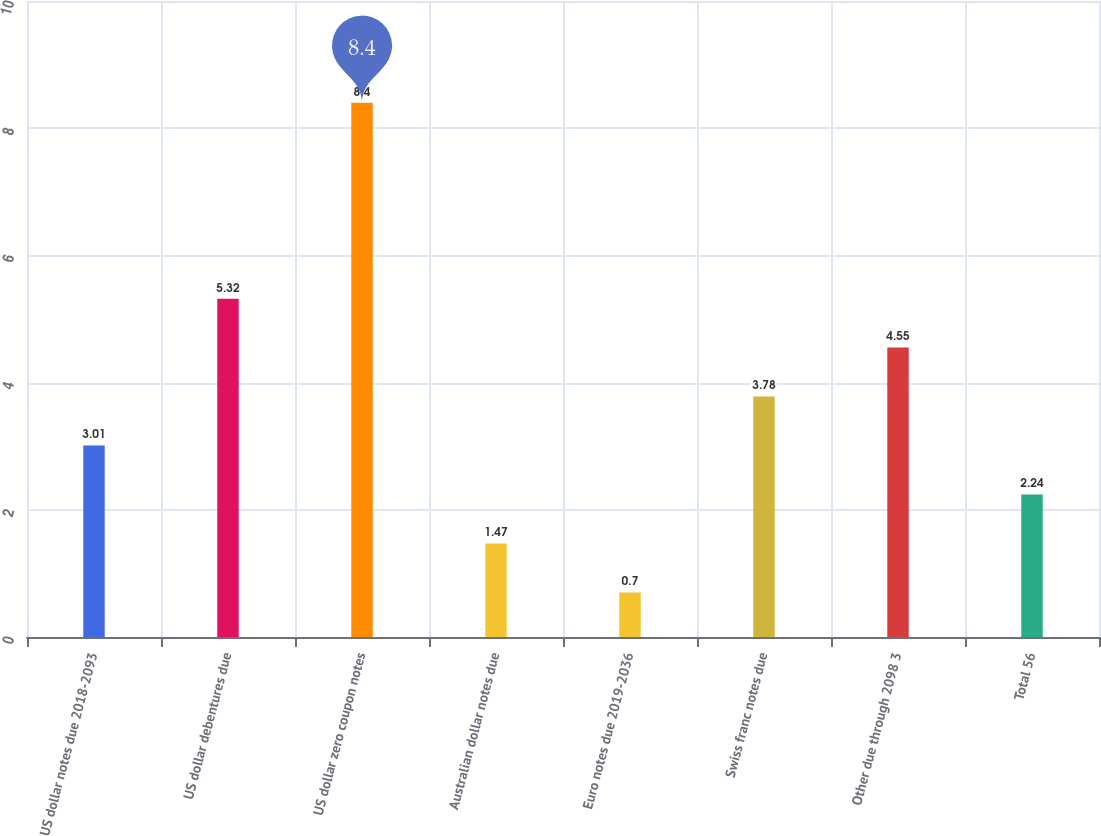Convert chart. <chart><loc_0><loc_0><loc_500><loc_500><bar_chart><fcel>US dollar notes due 2018-2093<fcel>US dollar debentures due<fcel>US dollar zero coupon notes<fcel>Australian dollar notes due<fcel>Euro notes due 2019-2036<fcel>Swiss franc notes due<fcel>Other due through 2098 3<fcel>Total 56<nl><fcel>3.01<fcel>5.32<fcel>8.4<fcel>1.47<fcel>0.7<fcel>3.78<fcel>4.55<fcel>2.24<nl></chart> 